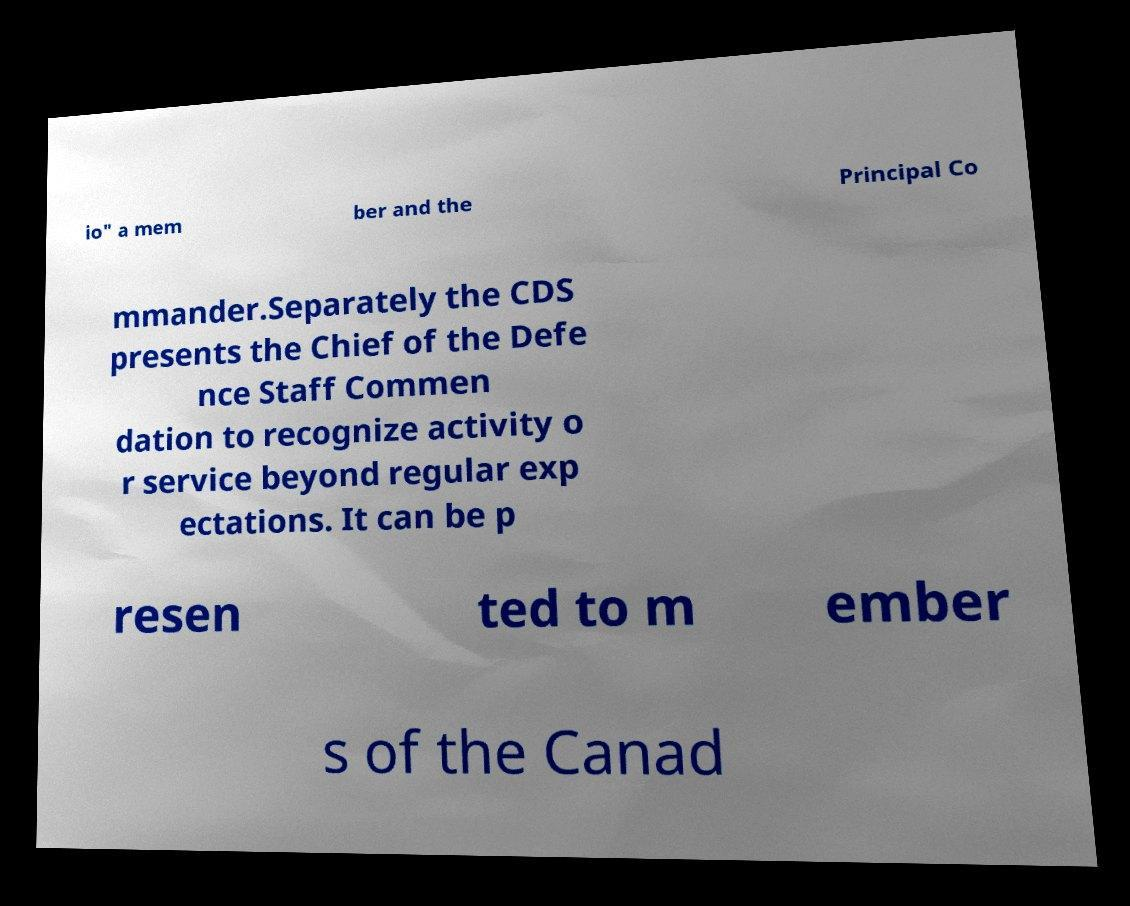I need the written content from this picture converted into text. Can you do that? io" a mem ber and the Principal Co mmander.Separately the CDS presents the Chief of the Defe nce Staff Commen dation to recognize activity o r service beyond regular exp ectations. It can be p resen ted to m ember s of the Canad 